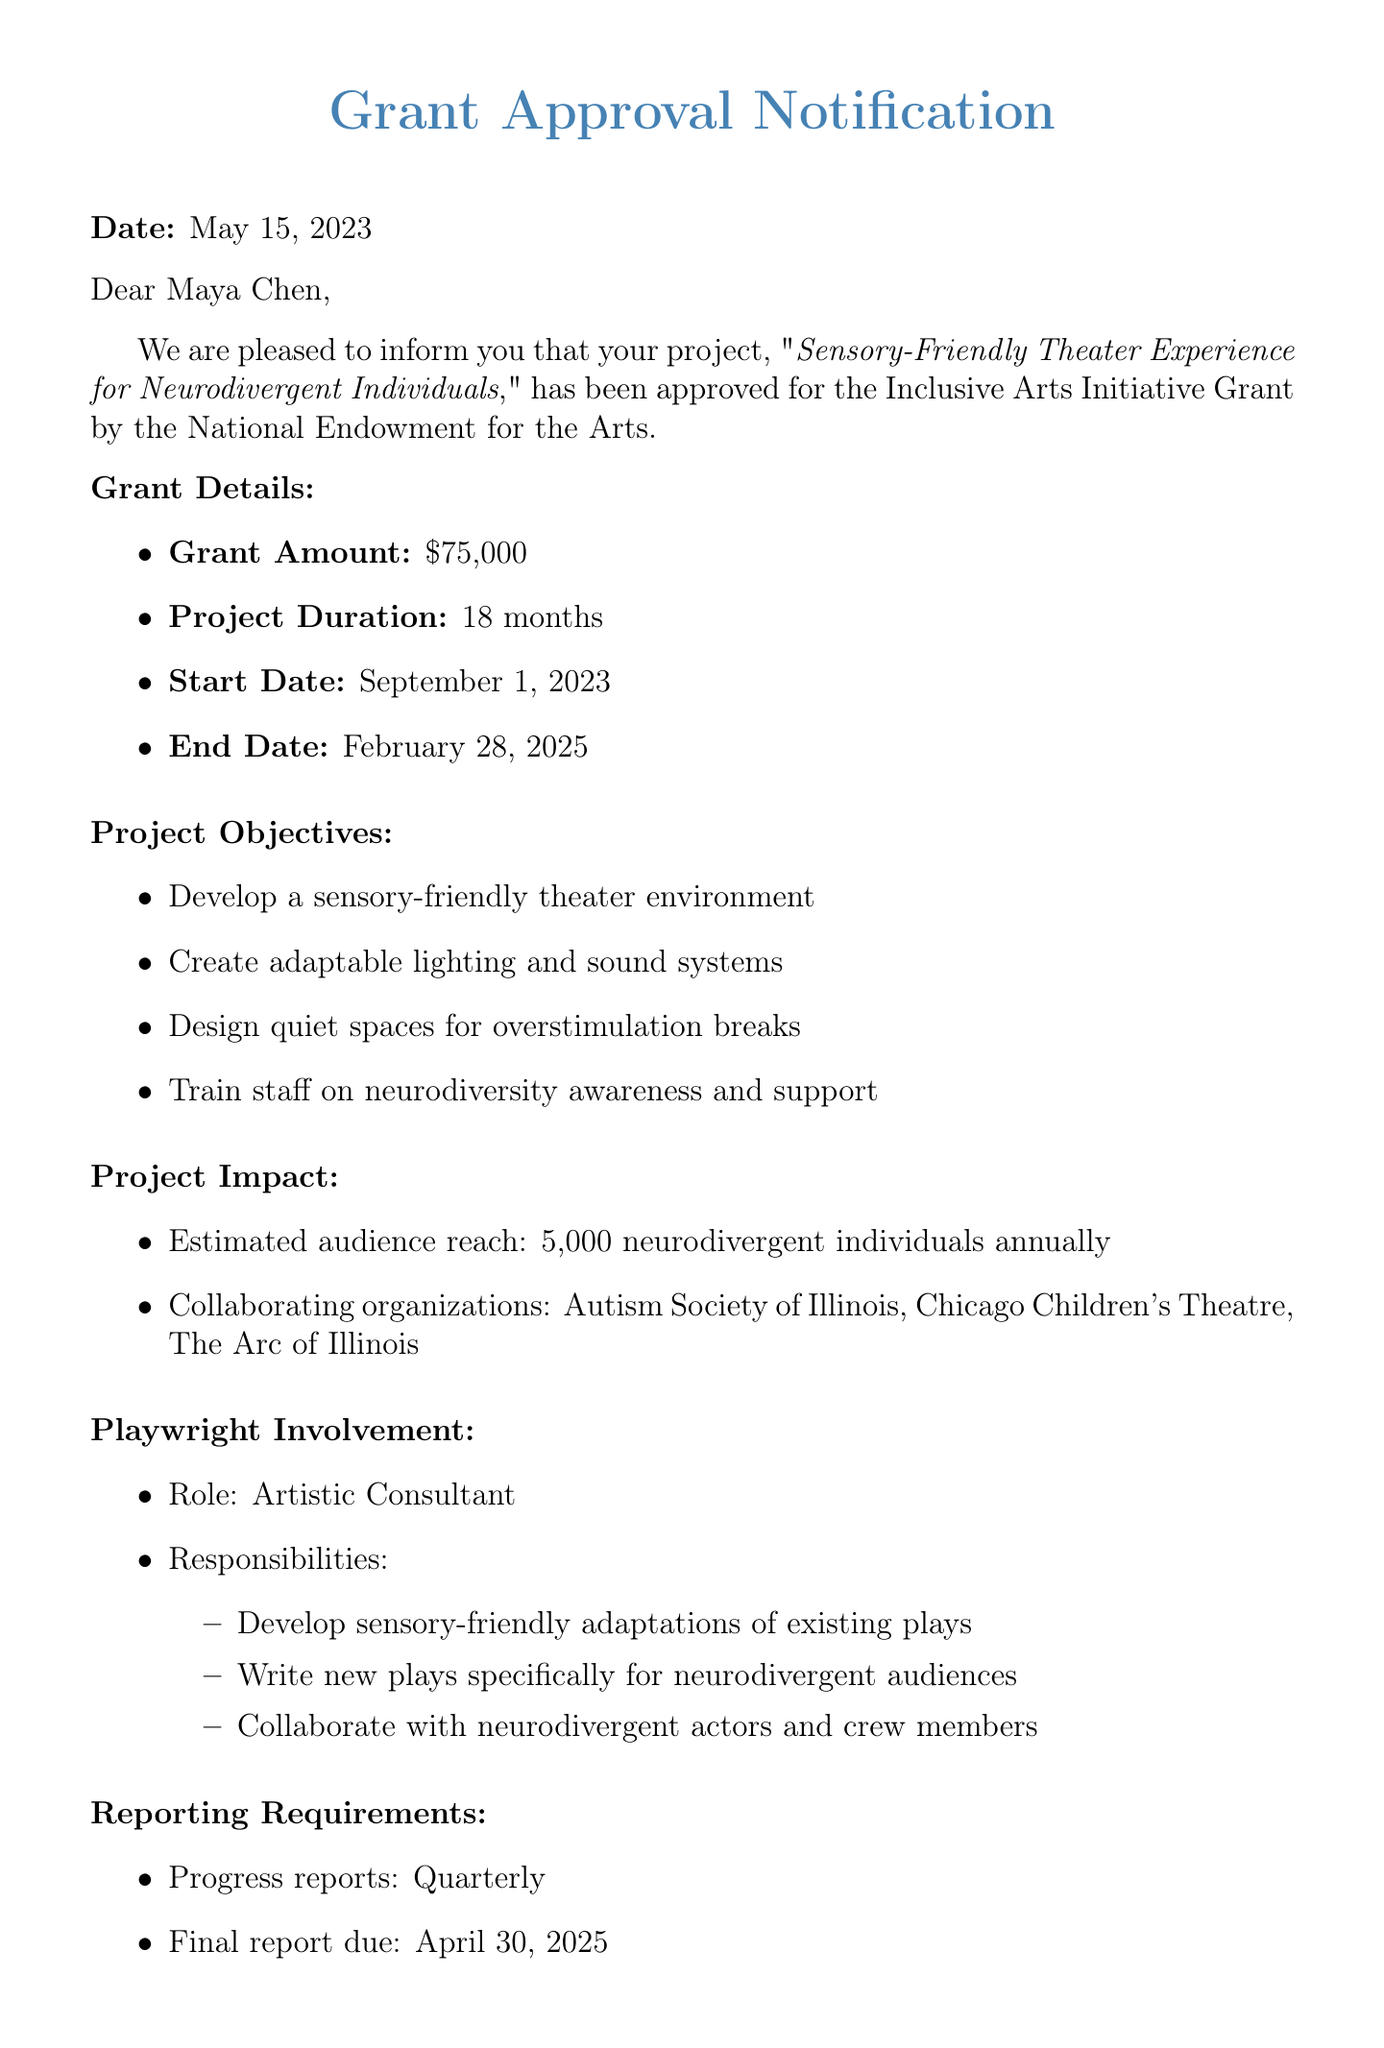What is the name of the grant? The name of the grant is specified in the document as "Inclusive Arts Initiative Grant."
Answer: Inclusive Arts Initiative Grant Who is the project lead? The document clearly states that the project lead is Maya Chen.
Answer: Maya Chen What is the total funding amount? The funding amount provided in the document is $75,000.
Answer: $75,000 When is the project scheduled to start? The start date of the project is mentioned as September 1, 2023.
Answer: September 1, 2023 What are the responsibilities of the playwright? The responsibilities include developing sensory-friendly adaptations, writing new plays, and collaborating with neurodivergent actors.
Answer: Develop sensory-friendly adaptations, write new plays, collaborate with neurodivergent actors What is the estimated audience reach? The estimated audience reach for the project is described as 5,000 neurodivergent individuals annually.
Answer: 5,000 neurodivergent individuals annually What are the reporting requirements? The reporting requirements include quarterly progress reports and a final report due on April 30, 2025.
Answer: Quarterly progress reports, final report due April 30, 2025 Who is the grant officer? The document states that the grant officer is Dr. Samantha Rodriguez.
Answer: Dr. Samantha Rodriguez What are the evaluation criteria for the project? The evaluation criteria include increased attendance, positive feedback, successful implementation of accessibility features, and community engagement.
Answer: Increased attendance, positive feedback, successful implementation, community engagement 